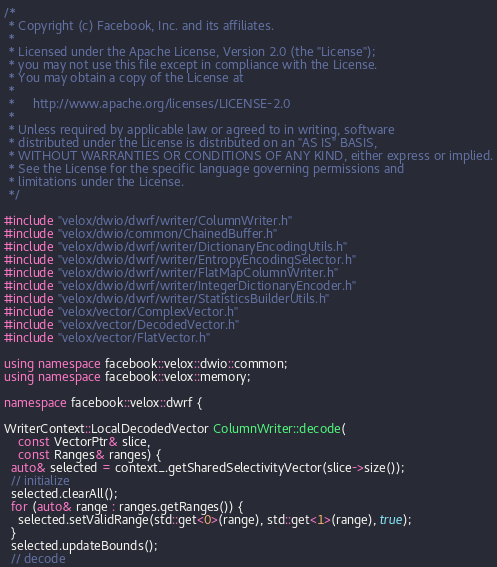<code> <loc_0><loc_0><loc_500><loc_500><_C++_>/*
 * Copyright (c) Facebook, Inc. and its affiliates.
 *
 * Licensed under the Apache License, Version 2.0 (the "License");
 * you may not use this file except in compliance with the License.
 * You may obtain a copy of the License at
 *
 *     http://www.apache.org/licenses/LICENSE-2.0
 *
 * Unless required by applicable law or agreed to in writing, software
 * distributed under the License is distributed on an "AS IS" BASIS,
 * WITHOUT WARRANTIES OR CONDITIONS OF ANY KIND, either express or implied.
 * See the License for the specific language governing permissions and
 * limitations under the License.
 */

#include "velox/dwio/dwrf/writer/ColumnWriter.h"
#include "velox/dwio/common/ChainedBuffer.h"
#include "velox/dwio/dwrf/writer/DictionaryEncodingUtils.h"
#include "velox/dwio/dwrf/writer/EntropyEncodingSelector.h"
#include "velox/dwio/dwrf/writer/FlatMapColumnWriter.h"
#include "velox/dwio/dwrf/writer/IntegerDictionaryEncoder.h"
#include "velox/dwio/dwrf/writer/StatisticsBuilderUtils.h"
#include "velox/vector/ComplexVector.h"
#include "velox/vector/DecodedVector.h"
#include "velox/vector/FlatVector.h"

using namespace facebook::velox::dwio::common;
using namespace facebook::velox::memory;

namespace facebook::velox::dwrf {

WriterContext::LocalDecodedVector ColumnWriter::decode(
    const VectorPtr& slice,
    const Ranges& ranges) {
  auto& selected = context_.getSharedSelectivityVector(slice->size());
  // initialize
  selected.clearAll();
  for (auto& range : ranges.getRanges()) {
    selected.setValidRange(std::get<0>(range), std::get<1>(range), true);
  }
  selected.updateBounds();
  // decode</code> 